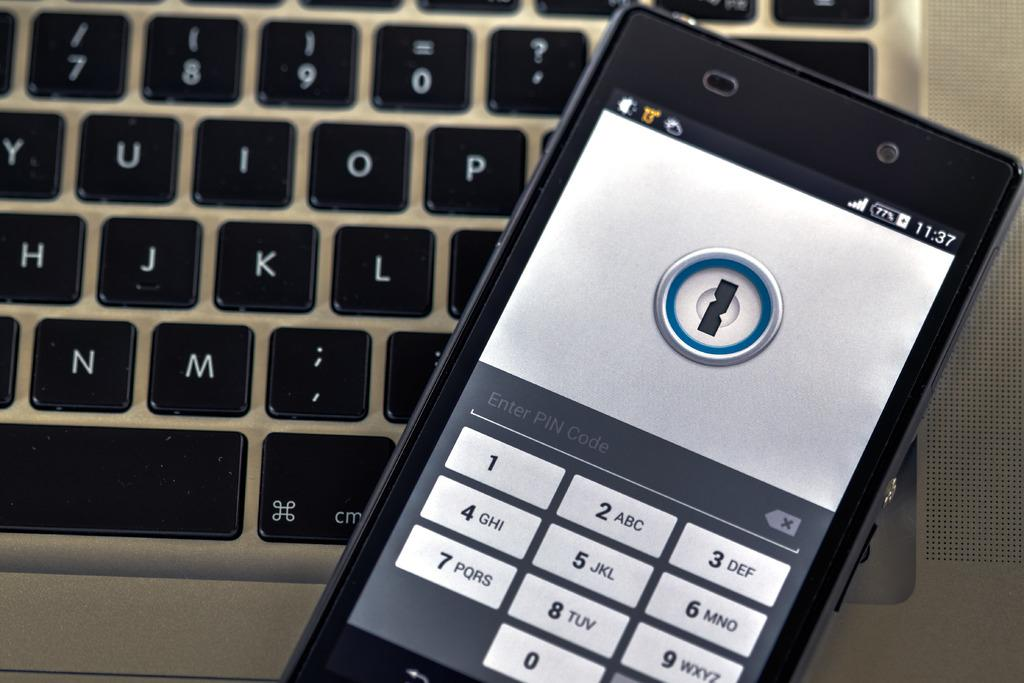<image>
Render a clear and concise summary of the photo. A smarphone waiting for the user to input their PIN code laying on a macbook keyboard. 